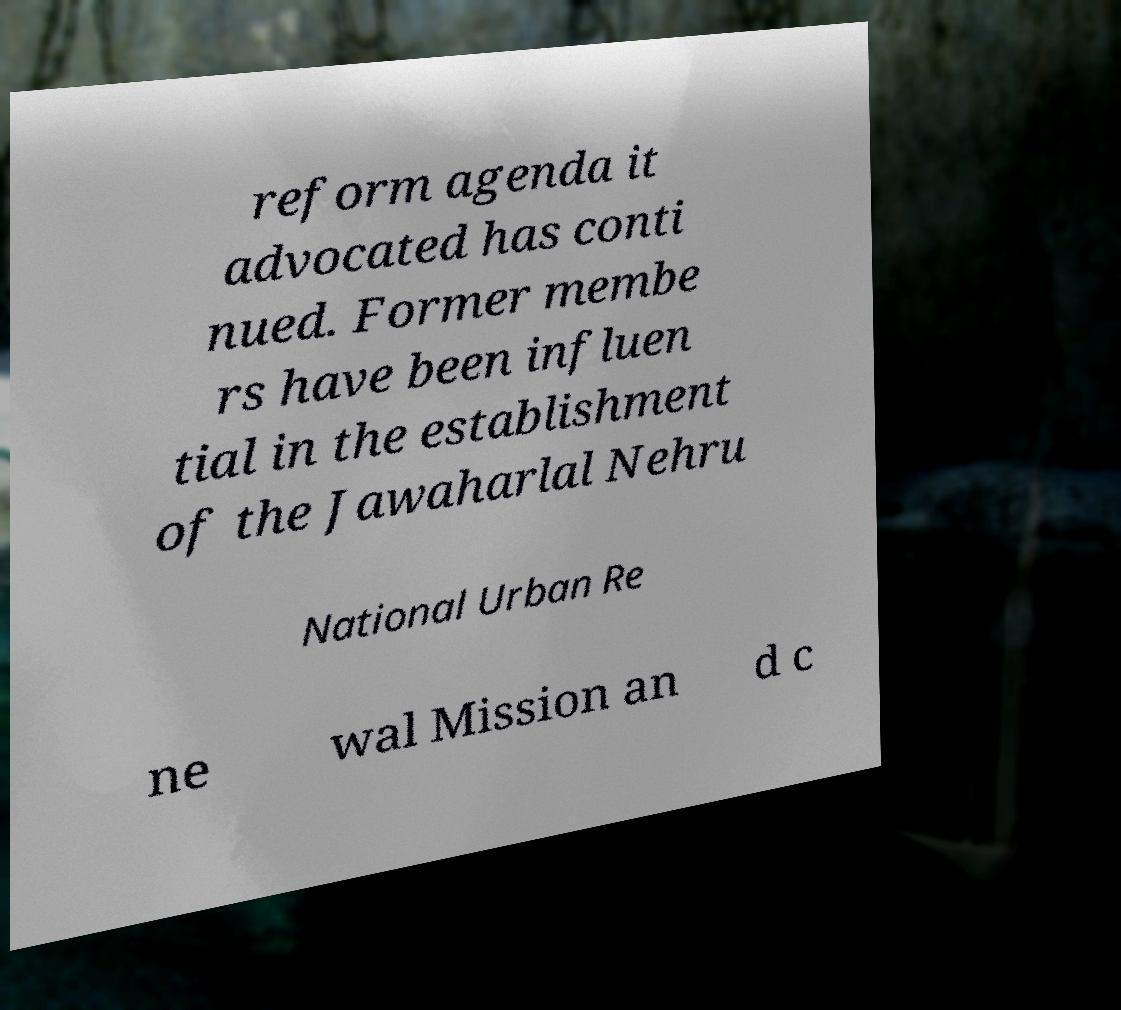I need the written content from this picture converted into text. Can you do that? reform agenda it advocated has conti nued. Former membe rs have been influen tial in the establishment of the Jawaharlal Nehru National Urban Re ne wal Mission an d c 